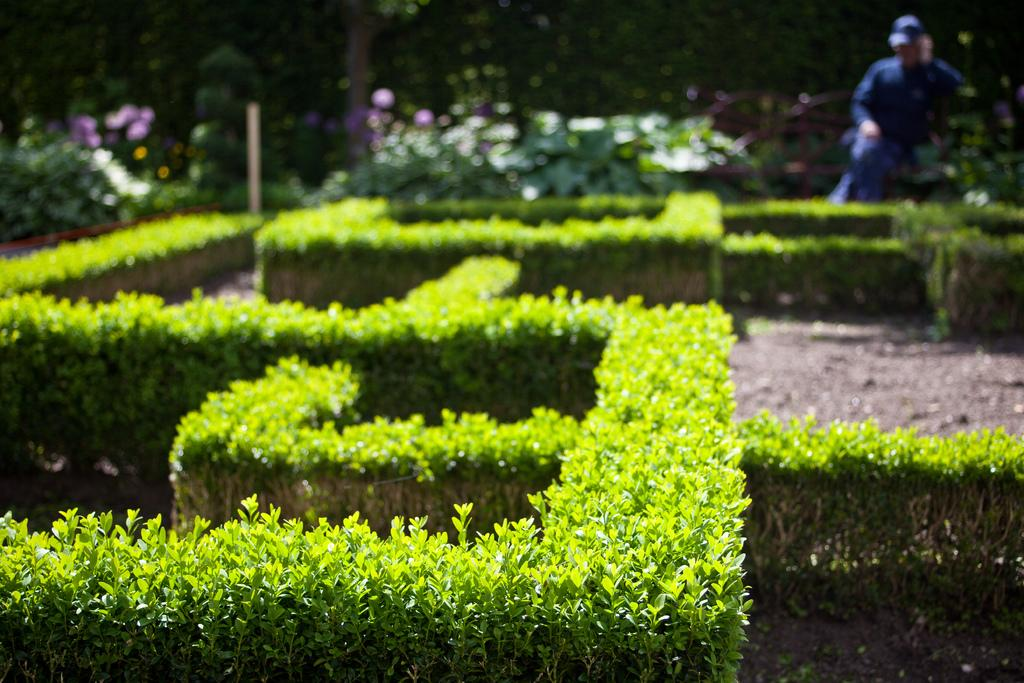What is the main feature in the front of the image? There is a shaped plant garden in the front of the image. Can you describe the person in the image? There is a man standing in the back of the image. What can be observed about the land in the image? Plants are present all over the land in the image. What type of seed is the man holding in the image? There is no seed visible in the image, nor is the man holding anything. 